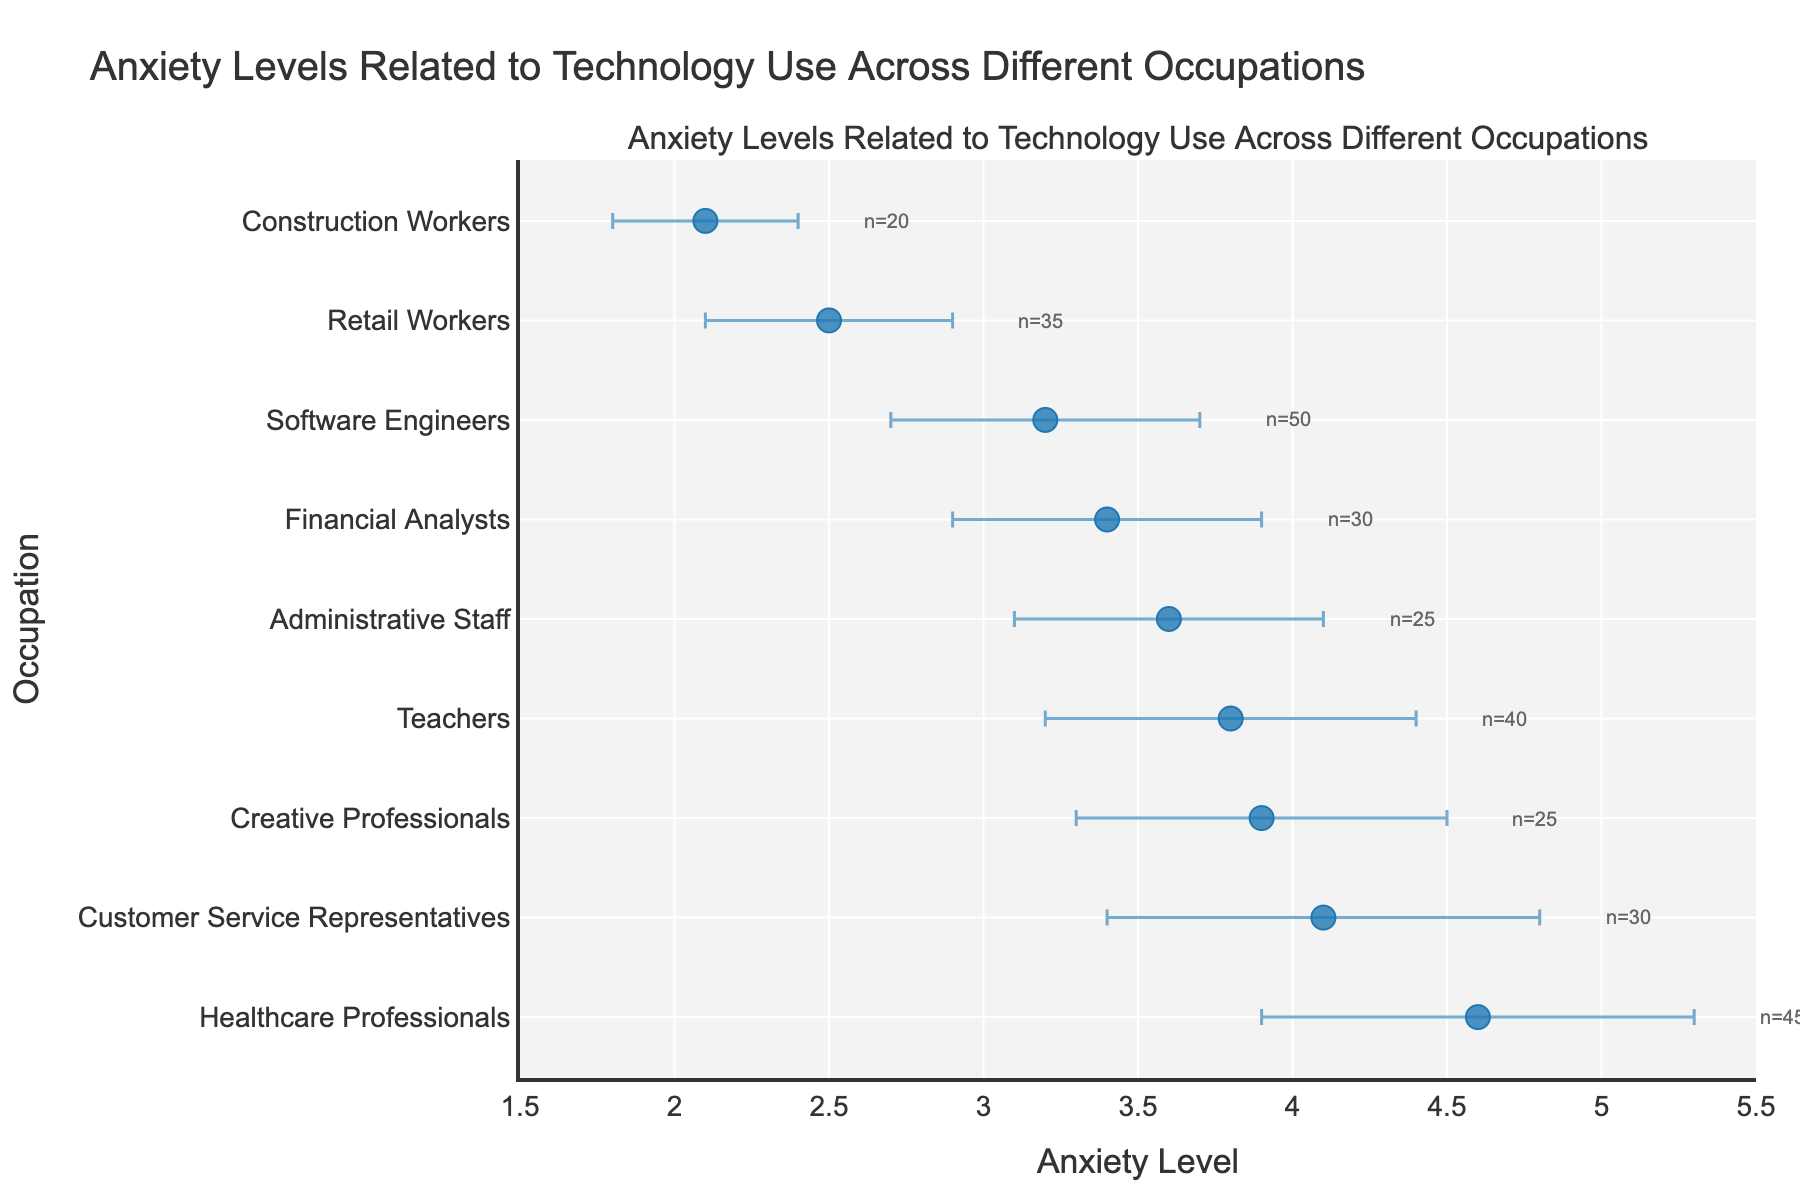What is the title of the plot? The title of the plot is located at the top center of the figure and provides a summary of what the plot depicts.
Answer: "Anxiety Levels Related to Technology Use Across Different Occupations" How many occupations are included in the plot? To determine the number of occupations, count the distinct categories on the y-axis.
Answer: 9 Which occupation has the highest mean anxiety level? To find this, look for the highest dot on the x-axis and match it to the corresponding occupation on the y-axis.
Answer: Healthcare Professionals Which occupation has the lowest mean anxiety level? To find this, look for the lowest dot on the x-axis and match it to the corresponding occupation on the y-axis.
Answer: Construction Workers What is the mean anxiety level of Software Engineers? Locate the dot representing Software Engineers on the y-axis and read its position on the x-axis.
Answer: 3.2 Which occupation has the largest standard deviation in anxiety levels? Compare the lengths of the error bars for each occupation and identify the longest one.
Answer: Healthcare Professionals Are there any occupations with similar anxiety levels? Look for dots that are placed closely to each other along the x-axis. For instance, if two or more dots are near the same x-axis value, those occupations have similar anxiety levels.
Answer: Administrative Staff and Software Engineers What is the mean difference in anxiety levels between Teachers and Retail Workers? Calculate the difference between the mean anxiety levels of Teachers (3.8) and Retail Workers (2.5).
Answer: 1.3 Which occupation has the smallest sample size and what is it? Look at the annotations next to each occupation, which indicate the sample size (n), and identify the smallest number.
Answer: Construction Workers (n=20) What is the range of anxiety levels represented in this plot? Find the highest mean anxiety level (Healthcare Professionals, 4.6) and the lowest mean anxiety level (Construction Workers, 2.1), and calculate the difference.
Answer: 2.5 